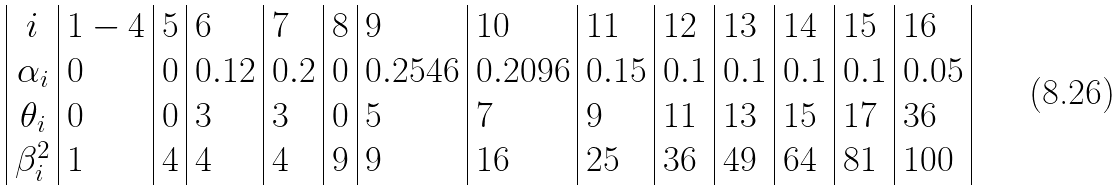<formula> <loc_0><loc_0><loc_500><loc_500>\begin{array} { | c | l | l | l | l | l | l | l | l | l | l | l | l | l | } i & 1 - 4 & 5 & 6 & 7 & 8 & 9 & 1 0 & 1 1 & 1 2 & 1 3 & 1 4 & 1 5 & 1 6 \\ \alpha _ { i } & 0 & 0 & 0 . 1 2 & 0 . 2 & 0 & 0 . 2 5 4 6 & 0 . 2 0 9 6 & 0 . 1 5 & 0 . 1 & 0 . 1 & 0 . 1 & 0 . 1 & 0 . 0 5 \\ \theta _ { i } & 0 & 0 & 3 & 3 & 0 & 5 & 7 & 9 & 1 1 & 1 3 & 1 5 & 1 7 & 3 6 \\ \beta _ { i } ^ { 2 } & 1 & 4 & 4 & 4 & 9 & 9 & 1 6 & 2 5 & 3 6 & 4 9 & 6 4 & 8 1 & 1 0 0 \\ \end{array}</formula> 